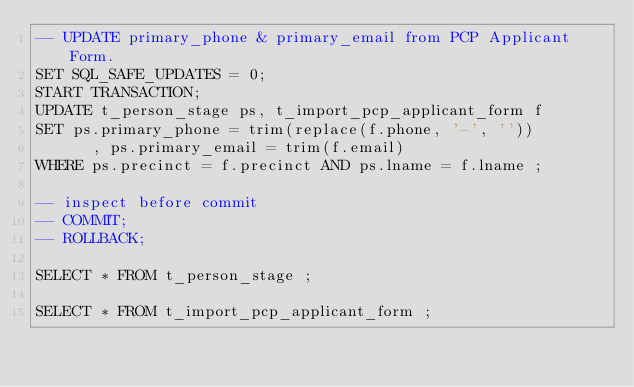Convert code to text. <code><loc_0><loc_0><loc_500><loc_500><_SQL_>-- UPDATE primary_phone & primary_email from PCP Applicant Form.
SET SQL_SAFE_UPDATES = 0;
START TRANSACTION;
UPDATE t_person_stage ps, t_import_pcp_applicant_form f 
SET ps.primary_phone = trim(replace(f.phone, '-', ''))
      , ps.primary_email = trim(f.email)
WHERE ps.precinct = f.precinct AND ps.lname = f.lname ;

-- inspect before commit
-- COMMIT;
-- ROLLBACK;

SELECT * FROM t_person_stage ;

SELECT * FROM t_import_pcp_applicant_form ;</code> 